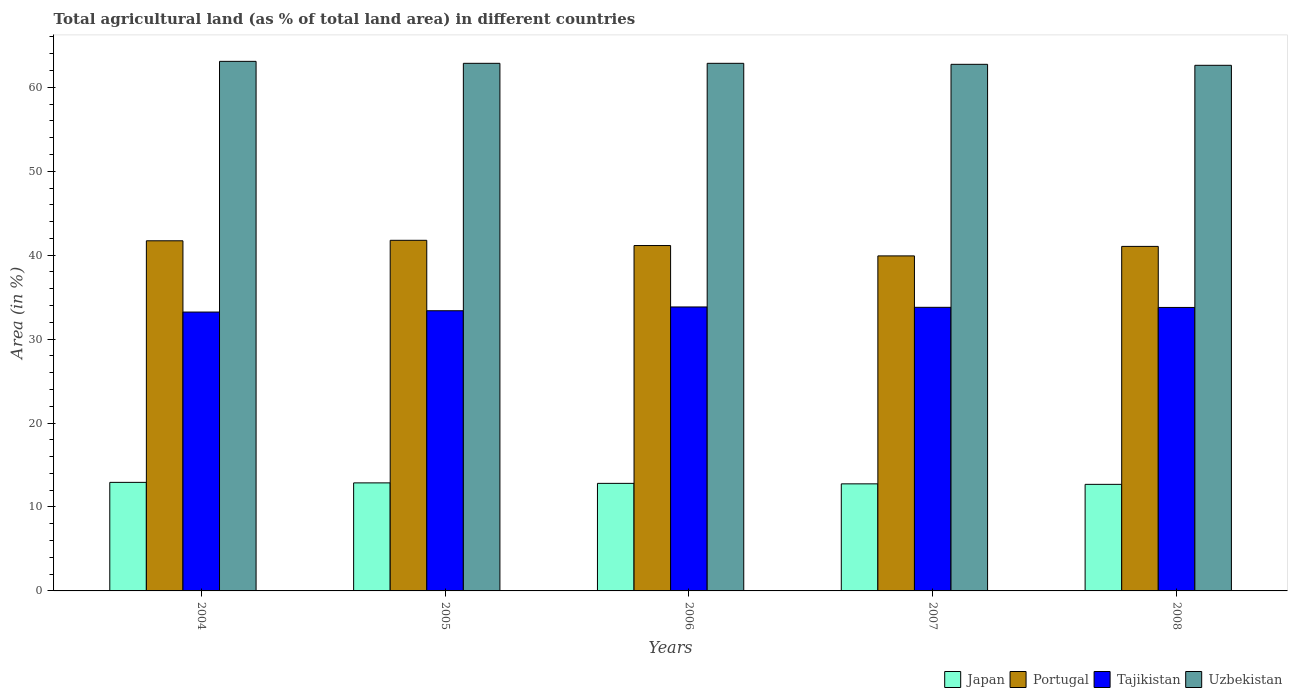Are the number of bars on each tick of the X-axis equal?
Provide a succinct answer. Yes. How many bars are there on the 3rd tick from the right?
Your answer should be very brief. 4. What is the label of the 5th group of bars from the left?
Your answer should be compact. 2008. What is the percentage of agricultural land in Japan in 2006?
Offer a terse response. 12.81. Across all years, what is the maximum percentage of agricultural land in Uzbekistan?
Give a very brief answer. 63.09. Across all years, what is the minimum percentage of agricultural land in Portugal?
Provide a short and direct response. 39.91. In which year was the percentage of agricultural land in Tajikistan maximum?
Your answer should be compact. 2006. In which year was the percentage of agricultural land in Tajikistan minimum?
Your answer should be very brief. 2004. What is the total percentage of agricultural land in Japan in the graph?
Ensure brevity in your answer.  64.07. What is the difference between the percentage of agricultural land in Uzbekistan in 2007 and that in 2008?
Provide a short and direct response. 0.12. What is the difference between the percentage of agricultural land in Japan in 2007 and the percentage of agricultural land in Uzbekistan in 2004?
Keep it short and to the point. -50.34. What is the average percentage of agricultural land in Japan per year?
Provide a short and direct response. 12.81. In the year 2007, what is the difference between the percentage of agricultural land in Japan and percentage of agricultural land in Tajikistan?
Provide a succinct answer. -21.03. What is the ratio of the percentage of agricultural land in Uzbekistan in 2007 to that in 2008?
Your response must be concise. 1. Is the difference between the percentage of agricultural land in Japan in 2007 and 2008 greater than the difference between the percentage of agricultural land in Tajikistan in 2007 and 2008?
Offer a terse response. Yes. What is the difference between the highest and the second highest percentage of agricultural land in Japan?
Offer a very short reply. 0.06. What is the difference between the highest and the lowest percentage of agricultural land in Uzbekistan?
Offer a terse response. 0.47. In how many years, is the percentage of agricultural land in Japan greater than the average percentage of agricultural land in Japan taken over all years?
Ensure brevity in your answer.  2. What does the 2nd bar from the right in 2005 represents?
Your answer should be very brief. Tajikistan. How many bars are there?
Ensure brevity in your answer.  20. Does the graph contain grids?
Your response must be concise. No. Where does the legend appear in the graph?
Ensure brevity in your answer.  Bottom right. What is the title of the graph?
Your response must be concise. Total agricultural land (as % of total land area) in different countries. What is the label or title of the Y-axis?
Ensure brevity in your answer.  Area (in %). What is the Area (in %) of Japan in 2004?
Keep it short and to the point. 12.93. What is the Area (in %) in Portugal in 2004?
Provide a short and direct response. 41.72. What is the Area (in %) in Tajikistan in 2004?
Provide a succinct answer. 33.22. What is the Area (in %) in Uzbekistan in 2004?
Make the answer very short. 63.09. What is the Area (in %) of Japan in 2005?
Provide a short and direct response. 12.87. What is the Area (in %) in Portugal in 2005?
Ensure brevity in your answer.  41.77. What is the Area (in %) in Tajikistan in 2005?
Offer a terse response. 33.38. What is the Area (in %) of Uzbekistan in 2005?
Provide a succinct answer. 62.86. What is the Area (in %) of Japan in 2006?
Make the answer very short. 12.81. What is the Area (in %) in Portugal in 2006?
Your response must be concise. 41.15. What is the Area (in %) in Tajikistan in 2006?
Offer a very short reply. 33.83. What is the Area (in %) of Uzbekistan in 2006?
Offer a terse response. 62.86. What is the Area (in %) of Japan in 2007?
Make the answer very short. 12.76. What is the Area (in %) of Portugal in 2007?
Provide a succinct answer. 39.91. What is the Area (in %) in Tajikistan in 2007?
Make the answer very short. 33.79. What is the Area (in %) in Uzbekistan in 2007?
Offer a terse response. 62.74. What is the Area (in %) in Japan in 2008?
Offer a very short reply. 12.7. What is the Area (in %) in Portugal in 2008?
Offer a very short reply. 41.05. What is the Area (in %) in Tajikistan in 2008?
Offer a terse response. 33.77. What is the Area (in %) of Uzbekistan in 2008?
Ensure brevity in your answer.  62.62. Across all years, what is the maximum Area (in %) in Japan?
Your answer should be very brief. 12.93. Across all years, what is the maximum Area (in %) in Portugal?
Your response must be concise. 41.77. Across all years, what is the maximum Area (in %) in Tajikistan?
Your answer should be compact. 33.83. Across all years, what is the maximum Area (in %) in Uzbekistan?
Keep it short and to the point. 63.09. Across all years, what is the minimum Area (in %) in Japan?
Offer a terse response. 12.7. Across all years, what is the minimum Area (in %) of Portugal?
Your response must be concise. 39.91. Across all years, what is the minimum Area (in %) in Tajikistan?
Give a very brief answer. 33.22. Across all years, what is the minimum Area (in %) in Uzbekistan?
Your answer should be very brief. 62.62. What is the total Area (in %) in Japan in the graph?
Offer a terse response. 64.07. What is the total Area (in %) of Portugal in the graph?
Ensure brevity in your answer.  205.6. What is the total Area (in %) of Tajikistan in the graph?
Ensure brevity in your answer.  168. What is the total Area (in %) in Uzbekistan in the graph?
Offer a terse response. 314.17. What is the difference between the Area (in %) in Japan in 2004 and that in 2005?
Offer a very short reply. 0.06. What is the difference between the Area (in %) of Portugal in 2004 and that in 2005?
Give a very brief answer. -0.06. What is the difference between the Area (in %) of Tajikistan in 2004 and that in 2005?
Your response must be concise. -0.16. What is the difference between the Area (in %) of Uzbekistan in 2004 and that in 2005?
Offer a very short reply. 0.24. What is the difference between the Area (in %) of Japan in 2004 and that in 2006?
Make the answer very short. 0.12. What is the difference between the Area (in %) in Portugal in 2004 and that in 2006?
Ensure brevity in your answer.  0.57. What is the difference between the Area (in %) in Tajikistan in 2004 and that in 2006?
Ensure brevity in your answer.  -0.61. What is the difference between the Area (in %) of Uzbekistan in 2004 and that in 2006?
Your answer should be very brief. 0.24. What is the difference between the Area (in %) of Japan in 2004 and that in 2007?
Provide a short and direct response. 0.18. What is the difference between the Area (in %) of Portugal in 2004 and that in 2007?
Offer a very short reply. 1.8. What is the difference between the Area (in %) of Tajikistan in 2004 and that in 2007?
Ensure brevity in your answer.  -0.56. What is the difference between the Area (in %) of Uzbekistan in 2004 and that in 2007?
Your answer should be compact. 0.35. What is the difference between the Area (in %) of Japan in 2004 and that in 2008?
Offer a terse response. 0.24. What is the difference between the Area (in %) in Portugal in 2004 and that in 2008?
Offer a very short reply. 0.67. What is the difference between the Area (in %) of Tajikistan in 2004 and that in 2008?
Your answer should be compact. -0.55. What is the difference between the Area (in %) of Uzbekistan in 2004 and that in 2008?
Provide a succinct answer. 0.47. What is the difference between the Area (in %) of Japan in 2005 and that in 2006?
Your answer should be very brief. 0.06. What is the difference between the Area (in %) in Portugal in 2005 and that in 2006?
Offer a very short reply. 0.62. What is the difference between the Area (in %) in Tajikistan in 2005 and that in 2006?
Make the answer very short. -0.45. What is the difference between the Area (in %) in Uzbekistan in 2005 and that in 2006?
Your answer should be compact. 0. What is the difference between the Area (in %) in Japan in 2005 and that in 2007?
Provide a short and direct response. 0.12. What is the difference between the Area (in %) of Portugal in 2005 and that in 2007?
Give a very brief answer. 1.86. What is the difference between the Area (in %) in Tajikistan in 2005 and that in 2007?
Your response must be concise. -0.41. What is the difference between the Area (in %) in Uzbekistan in 2005 and that in 2007?
Offer a very short reply. 0.12. What is the difference between the Area (in %) in Japan in 2005 and that in 2008?
Ensure brevity in your answer.  0.18. What is the difference between the Area (in %) of Portugal in 2005 and that in 2008?
Offer a terse response. 0.73. What is the difference between the Area (in %) of Tajikistan in 2005 and that in 2008?
Keep it short and to the point. -0.39. What is the difference between the Area (in %) in Uzbekistan in 2005 and that in 2008?
Ensure brevity in your answer.  0.24. What is the difference between the Area (in %) of Japan in 2006 and that in 2007?
Your response must be concise. 0.06. What is the difference between the Area (in %) of Portugal in 2006 and that in 2007?
Your answer should be compact. 1.24. What is the difference between the Area (in %) of Tajikistan in 2006 and that in 2007?
Ensure brevity in your answer.  0.04. What is the difference between the Area (in %) in Uzbekistan in 2006 and that in 2007?
Your answer should be very brief. 0.12. What is the difference between the Area (in %) in Japan in 2006 and that in 2008?
Your answer should be compact. 0.12. What is the difference between the Area (in %) of Portugal in 2006 and that in 2008?
Your answer should be compact. 0.1. What is the difference between the Area (in %) in Tajikistan in 2006 and that in 2008?
Your response must be concise. 0.06. What is the difference between the Area (in %) in Uzbekistan in 2006 and that in 2008?
Provide a short and direct response. 0.24. What is the difference between the Area (in %) of Japan in 2007 and that in 2008?
Your answer should be very brief. 0.06. What is the difference between the Area (in %) of Portugal in 2007 and that in 2008?
Provide a succinct answer. -1.13. What is the difference between the Area (in %) of Tajikistan in 2007 and that in 2008?
Your response must be concise. 0.01. What is the difference between the Area (in %) of Uzbekistan in 2007 and that in 2008?
Provide a succinct answer. 0.12. What is the difference between the Area (in %) in Japan in 2004 and the Area (in %) in Portugal in 2005?
Your response must be concise. -28.84. What is the difference between the Area (in %) of Japan in 2004 and the Area (in %) of Tajikistan in 2005?
Keep it short and to the point. -20.45. What is the difference between the Area (in %) in Japan in 2004 and the Area (in %) in Uzbekistan in 2005?
Keep it short and to the point. -49.93. What is the difference between the Area (in %) in Portugal in 2004 and the Area (in %) in Tajikistan in 2005?
Provide a succinct answer. 8.33. What is the difference between the Area (in %) in Portugal in 2004 and the Area (in %) in Uzbekistan in 2005?
Ensure brevity in your answer.  -21.14. What is the difference between the Area (in %) in Tajikistan in 2004 and the Area (in %) in Uzbekistan in 2005?
Provide a short and direct response. -29.63. What is the difference between the Area (in %) in Japan in 2004 and the Area (in %) in Portugal in 2006?
Your answer should be very brief. -28.22. What is the difference between the Area (in %) of Japan in 2004 and the Area (in %) of Tajikistan in 2006?
Ensure brevity in your answer.  -20.9. What is the difference between the Area (in %) of Japan in 2004 and the Area (in %) of Uzbekistan in 2006?
Your response must be concise. -49.93. What is the difference between the Area (in %) of Portugal in 2004 and the Area (in %) of Tajikistan in 2006?
Your response must be concise. 7.88. What is the difference between the Area (in %) in Portugal in 2004 and the Area (in %) in Uzbekistan in 2006?
Your answer should be very brief. -21.14. What is the difference between the Area (in %) of Tajikistan in 2004 and the Area (in %) of Uzbekistan in 2006?
Offer a terse response. -29.63. What is the difference between the Area (in %) of Japan in 2004 and the Area (in %) of Portugal in 2007?
Ensure brevity in your answer.  -26.98. What is the difference between the Area (in %) of Japan in 2004 and the Area (in %) of Tajikistan in 2007?
Offer a terse response. -20.86. What is the difference between the Area (in %) of Japan in 2004 and the Area (in %) of Uzbekistan in 2007?
Your answer should be very brief. -49.81. What is the difference between the Area (in %) of Portugal in 2004 and the Area (in %) of Tajikistan in 2007?
Offer a very short reply. 7.93. What is the difference between the Area (in %) in Portugal in 2004 and the Area (in %) in Uzbekistan in 2007?
Keep it short and to the point. -21.03. What is the difference between the Area (in %) of Tajikistan in 2004 and the Area (in %) of Uzbekistan in 2007?
Make the answer very short. -29.52. What is the difference between the Area (in %) of Japan in 2004 and the Area (in %) of Portugal in 2008?
Give a very brief answer. -28.11. What is the difference between the Area (in %) in Japan in 2004 and the Area (in %) in Tajikistan in 2008?
Provide a succinct answer. -20.84. What is the difference between the Area (in %) of Japan in 2004 and the Area (in %) of Uzbekistan in 2008?
Your answer should be compact. -49.69. What is the difference between the Area (in %) in Portugal in 2004 and the Area (in %) in Tajikistan in 2008?
Provide a short and direct response. 7.94. What is the difference between the Area (in %) of Portugal in 2004 and the Area (in %) of Uzbekistan in 2008?
Your response must be concise. -20.91. What is the difference between the Area (in %) of Tajikistan in 2004 and the Area (in %) of Uzbekistan in 2008?
Make the answer very short. -29.4. What is the difference between the Area (in %) of Japan in 2005 and the Area (in %) of Portugal in 2006?
Offer a very short reply. -28.28. What is the difference between the Area (in %) of Japan in 2005 and the Area (in %) of Tajikistan in 2006?
Ensure brevity in your answer.  -20.96. What is the difference between the Area (in %) of Japan in 2005 and the Area (in %) of Uzbekistan in 2006?
Offer a terse response. -49.99. What is the difference between the Area (in %) of Portugal in 2005 and the Area (in %) of Tajikistan in 2006?
Provide a short and direct response. 7.94. What is the difference between the Area (in %) in Portugal in 2005 and the Area (in %) in Uzbekistan in 2006?
Give a very brief answer. -21.09. What is the difference between the Area (in %) in Tajikistan in 2005 and the Area (in %) in Uzbekistan in 2006?
Give a very brief answer. -29.48. What is the difference between the Area (in %) of Japan in 2005 and the Area (in %) of Portugal in 2007?
Your response must be concise. -27.04. What is the difference between the Area (in %) of Japan in 2005 and the Area (in %) of Tajikistan in 2007?
Offer a very short reply. -20.92. What is the difference between the Area (in %) of Japan in 2005 and the Area (in %) of Uzbekistan in 2007?
Your answer should be very brief. -49.87. What is the difference between the Area (in %) of Portugal in 2005 and the Area (in %) of Tajikistan in 2007?
Ensure brevity in your answer.  7.99. What is the difference between the Area (in %) in Portugal in 2005 and the Area (in %) in Uzbekistan in 2007?
Your answer should be compact. -20.97. What is the difference between the Area (in %) of Tajikistan in 2005 and the Area (in %) of Uzbekistan in 2007?
Provide a succinct answer. -29.36. What is the difference between the Area (in %) of Japan in 2005 and the Area (in %) of Portugal in 2008?
Your answer should be compact. -28.17. What is the difference between the Area (in %) in Japan in 2005 and the Area (in %) in Tajikistan in 2008?
Give a very brief answer. -20.9. What is the difference between the Area (in %) of Japan in 2005 and the Area (in %) of Uzbekistan in 2008?
Offer a very short reply. -49.75. What is the difference between the Area (in %) of Portugal in 2005 and the Area (in %) of Tajikistan in 2008?
Your response must be concise. 8. What is the difference between the Area (in %) of Portugal in 2005 and the Area (in %) of Uzbekistan in 2008?
Provide a succinct answer. -20.85. What is the difference between the Area (in %) in Tajikistan in 2005 and the Area (in %) in Uzbekistan in 2008?
Provide a succinct answer. -29.24. What is the difference between the Area (in %) in Japan in 2006 and the Area (in %) in Portugal in 2007?
Offer a terse response. -27.1. What is the difference between the Area (in %) of Japan in 2006 and the Area (in %) of Tajikistan in 2007?
Your response must be concise. -20.97. What is the difference between the Area (in %) of Japan in 2006 and the Area (in %) of Uzbekistan in 2007?
Provide a short and direct response. -49.93. What is the difference between the Area (in %) in Portugal in 2006 and the Area (in %) in Tajikistan in 2007?
Your response must be concise. 7.36. What is the difference between the Area (in %) in Portugal in 2006 and the Area (in %) in Uzbekistan in 2007?
Keep it short and to the point. -21.59. What is the difference between the Area (in %) in Tajikistan in 2006 and the Area (in %) in Uzbekistan in 2007?
Provide a succinct answer. -28.91. What is the difference between the Area (in %) of Japan in 2006 and the Area (in %) of Portugal in 2008?
Give a very brief answer. -28.23. What is the difference between the Area (in %) in Japan in 2006 and the Area (in %) in Tajikistan in 2008?
Keep it short and to the point. -20.96. What is the difference between the Area (in %) of Japan in 2006 and the Area (in %) of Uzbekistan in 2008?
Offer a very short reply. -49.81. What is the difference between the Area (in %) of Portugal in 2006 and the Area (in %) of Tajikistan in 2008?
Your answer should be very brief. 7.38. What is the difference between the Area (in %) in Portugal in 2006 and the Area (in %) in Uzbekistan in 2008?
Offer a terse response. -21.47. What is the difference between the Area (in %) in Tajikistan in 2006 and the Area (in %) in Uzbekistan in 2008?
Make the answer very short. -28.79. What is the difference between the Area (in %) of Japan in 2007 and the Area (in %) of Portugal in 2008?
Make the answer very short. -28.29. What is the difference between the Area (in %) of Japan in 2007 and the Area (in %) of Tajikistan in 2008?
Give a very brief answer. -21.02. What is the difference between the Area (in %) of Japan in 2007 and the Area (in %) of Uzbekistan in 2008?
Offer a very short reply. -49.87. What is the difference between the Area (in %) in Portugal in 2007 and the Area (in %) in Tajikistan in 2008?
Your response must be concise. 6.14. What is the difference between the Area (in %) in Portugal in 2007 and the Area (in %) in Uzbekistan in 2008?
Give a very brief answer. -22.71. What is the difference between the Area (in %) in Tajikistan in 2007 and the Area (in %) in Uzbekistan in 2008?
Your answer should be very brief. -28.84. What is the average Area (in %) of Japan per year?
Give a very brief answer. 12.81. What is the average Area (in %) in Portugal per year?
Your answer should be compact. 41.12. What is the average Area (in %) in Tajikistan per year?
Your response must be concise. 33.6. What is the average Area (in %) of Uzbekistan per year?
Give a very brief answer. 62.84. In the year 2004, what is the difference between the Area (in %) of Japan and Area (in %) of Portugal?
Provide a succinct answer. -28.78. In the year 2004, what is the difference between the Area (in %) of Japan and Area (in %) of Tajikistan?
Give a very brief answer. -20.29. In the year 2004, what is the difference between the Area (in %) of Japan and Area (in %) of Uzbekistan?
Your answer should be compact. -50.16. In the year 2004, what is the difference between the Area (in %) of Portugal and Area (in %) of Tajikistan?
Provide a short and direct response. 8.49. In the year 2004, what is the difference between the Area (in %) in Portugal and Area (in %) in Uzbekistan?
Keep it short and to the point. -21.38. In the year 2004, what is the difference between the Area (in %) of Tajikistan and Area (in %) of Uzbekistan?
Your answer should be compact. -29.87. In the year 2005, what is the difference between the Area (in %) of Japan and Area (in %) of Portugal?
Your answer should be compact. -28.9. In the year 2005, what is the difference between the Area (in %) of Japan and Area (in %) of Tajikistan?
Your response must be concise. -20.51. In the year 2005, what is the difference between the Area (in %) in Japan and Area (in %) in Uzbekistan?
Make the answer very short. -49.99. In the year 2005, what is the difference between the Area (in %) of Portugal and Area (in %) of Tajikistan?
Provide a succinct answer. 8.39. In the year 2005, what is the difference between the Area (in %) in Portugal and Area (in %) in Uzbekistan?
Your answer should be compact. -21.09. In the year 2005, what is the difference between the Area (in %) in Tajikistan and Area (in %) in Uzbekistan?
Your answer should be compact. -29.48. In the year 2006, what is the difference between the Area (in %) in Japan and Area (in %) in Portugal?
Your answer should be compact. -28.34. In the year 2006, what is the difference between the Area (in %) of Japan and Area (in %) of Tajikistan?
Make the answer very short. -21.02. In the year 2006, what is the difference between the Area (in %) of Japan and Area (in %) of Uzbekistan?
Offer a very short reply. -50.04. In the year 2006, what is the difference between the Area (in %) in Portugal and Area (in %) in Tajikistan?
Give a very brief answer. 7.32. In the year 2006, what is the difference between the Area (in %) in Portugal and Area (in %) in Uzbekistan?
Provide a short and direct response. -21.71. In the year 2006, what is the difference between the Area (in %) in Tajikistan and Area (in %) in Uzbekistan?
Your answer should be very brief. -29.03. In the year 2007, what is the difference between the Area (in %) of Japan and Area (in %) of Portugal?
Your response must be concise. -27.16. In the year 2007, what is the difference between the Area (in %) in Japan and Area (in %) in Tajikistan?
Keep it short and to the point. -21.03. In the year 2007, what is the difference between the Area (in %) in Japan and Area (in %) in Uzbekistan?
Your answer should be very brief. -49.98. In the year 2007, what is the difference between the Area (in %) of Portugal and Area (in %) of Tajikistan?
Your answer should be compact. 6.13. In the year 2007, what is the difference between the Area (in %) of Portugal and Area (in %) of Uzbekistan?
Give a very brief answer. -22.83. In the year 2007, what is the difference between the Area (in %) in Tajikistan and Area (in %) in Uzbekistan?
Your answer should be compact. -28.95. In the year 2008, what is the difference between the Area (in %) in Japan and Area (in %) in Portugal?
Provide a succinct answer. -28.35. In the year 2008, what is the difference between the Area (in %) of Japan and Area (in %) of Tajikistan?
Offer a terse response. -21.08. In the year 2008, what is the difference between the Area (in %) in Japan and Area (in %) in Uzbekistan?
Your answer should be compact. -49.93. In the year 2008, what is the difference between the Area (in %) of Portugal and Area (in %) of Tajikistan?
Provide a succinct answer. 7.27. In the year 2008, what is the difference between the Area (in %) in Portugal and Area (in %) in Uzbekistan?
Give a very brief answer. -21.58. In the year 2008, what is the difference between the Area (in %) in Tajikistan and Area (in %) in Uzbekistan?
Offer a very short reply. -28.85. What is the ratio of the Area (in %) in Japan in 2004 to that in 2006?
Offer a very short reply. 1.01. What is the ratio of the Area (in %) of Portugal in 2004 to that in 2006?
Give a very brief answer. 1.01. What is the ratio of the Area (in %) in Japan in 2004 to that in 2007?
Offer a terse response. 1.01. What is the ratio of the Area (in %) in Portugal in 2004 to that in 2007?
Your answer should be compact. 1.05. What is the ratio of the Area (in %) of Tajikistan in 2004 to that in 2007?
Keep it short and to the point. 0.98. What is the ratio of the Area (in %) of Uzbekistan in 2004 to that in 2007?
Your response must be concise. 1.01. What is the ratio of the Area (in %) in Japan in 2004 to that in 2008?
Provide a succinct answer. 1.02. What is the ratio of the Area (in %) in Portugal in 2004 to that in 2008?
Your answer should be compact. 1.02. What is the ratio of the Area (in %) of Tajikistan in 2004 to that in 2008?
Ensure brevity in your answer.  0.98. What is the ratio of the Area (in %) in Uzbekistan in 2004 to that in 2008?
Provide a short and direct response. 1.01. What is the ratio of the Area (in %) of Portugal in 2005 to that in 2006?
Offer a terse response. 1.02. What is the ratio of the Area (in %) of Tajikistan in 2005 to that in 2006?
Make the answer very short. 0.99. What is the ratio of the Area (in %) of Portugal in 2005 to that in 2007?
Ensure brevity in your answer.  1.05. What is the ratio of the Area (in %) of Tajikistan in 2005 to that in 2007?
Offer a terse response. 0.99. What is the ratio of the Area (in %) in Uzbekistan in 2005 to that in 2007?
Keep it short and to the point. 1. What is the ratio of the Area (in %) of Japan in 2005 to that in 2008?
Your answer should be very brief. 1.01. What is the ratio of the Area (in %) in Portugal in 2005 to that in 2008?
Offer a terse response. 1.02. What is the ratio of the Area (in %) of Tajikistan in 2005 to that in 2008?
Your answer should be very brief. 0.99. What is the ratio of the Area (in %) of Uzbekistan in 2005 to that in 2008?
Keep it short and to the point. 1. What is the ratio of the Area (in %) of Portugal in 2006 to that in 2007?
Keep it short and to the point. 1.03. What is the ratio of the Area (in %) in Uzbekistan in 2006 to that in 2007?
Offer a very short reply. 1. What is the ratio of the Area (in %) in Japan in 2006 to that in 2008?
Make the answer very short. 1.01. What is the ratio of the Area (in %) in Tajikistan in 2006 to that in 2008?
Your answer should be compact. 1. What is the ratio of the Area (in %) of Japan in 2007 to that in 2008?
Your answer should be compact. 1. What is the ratio of the Area (in %) of Portugal in 2007 to that in 2008?
Offer a terse response. 0.97. What is the ratio of the Area (in %) of Uzbekistan in 2007 to that in 2008?
Your response must be concise. 1. What is the difference between the highest and the second highest Area (in %) in Japan?
Provide a short and direct response. 0.06. What is the difference between the highest and the second highest Area (in %) of Portugal?
Your answer should be very brief. 0.06. What is the difference between the highest and the second highest Area (in %) of Tajikistan?
Make the answer very short. 0.04. What is the difference between the highest and the second highest Area (in %) in Uzbekistan?
Provide a succinct answer. 0.24. What is the difference between the highest and the lowest Area (in %) of Japan?
Your answer should be compact. 0.24. What is the difference between the highest and the lowest Area (in %) of Portugal?
Your response must be concise. 1.86. What is the difference between the highest and the lowest Area (in %) in Tajikistan?
Your answer should be very brief. 0.61. What is the difference between the highest and the lowest Area (in %) of Uzbekistan?
Provide a succinct answer. 0.47. 